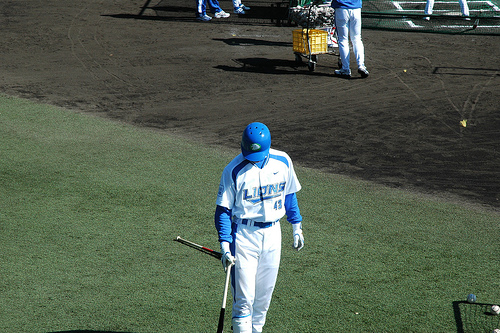<image>
Is the ball to the left of the man? No. The ball is not to the left of the man. From this viewpoint, they have a different horizontal relationship. Is there a bucket in front of the legs? Yes. The bucket is positioned in front of the legs, appearing closer to the camera viewpoint. 